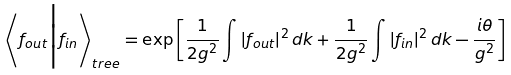<formula> <loc_0><loc_0><loc_500><loc_500>\left \langle f _ { o u t } \Big | f _ { i n } \right \rangle _ { t r e e } = \exp \left [ \frac { 1 } { 2 g ^ { 2 } } \int \left | f _ { o u t } \right | ^ { 2 } d k + \frac { 1 } { 2 g ^ { 2 } } \int \left | f _ { i n } \right | ^ { 2 } d k - \frac { i \theta } { g ^ { 2 } } \right ]</formula> 